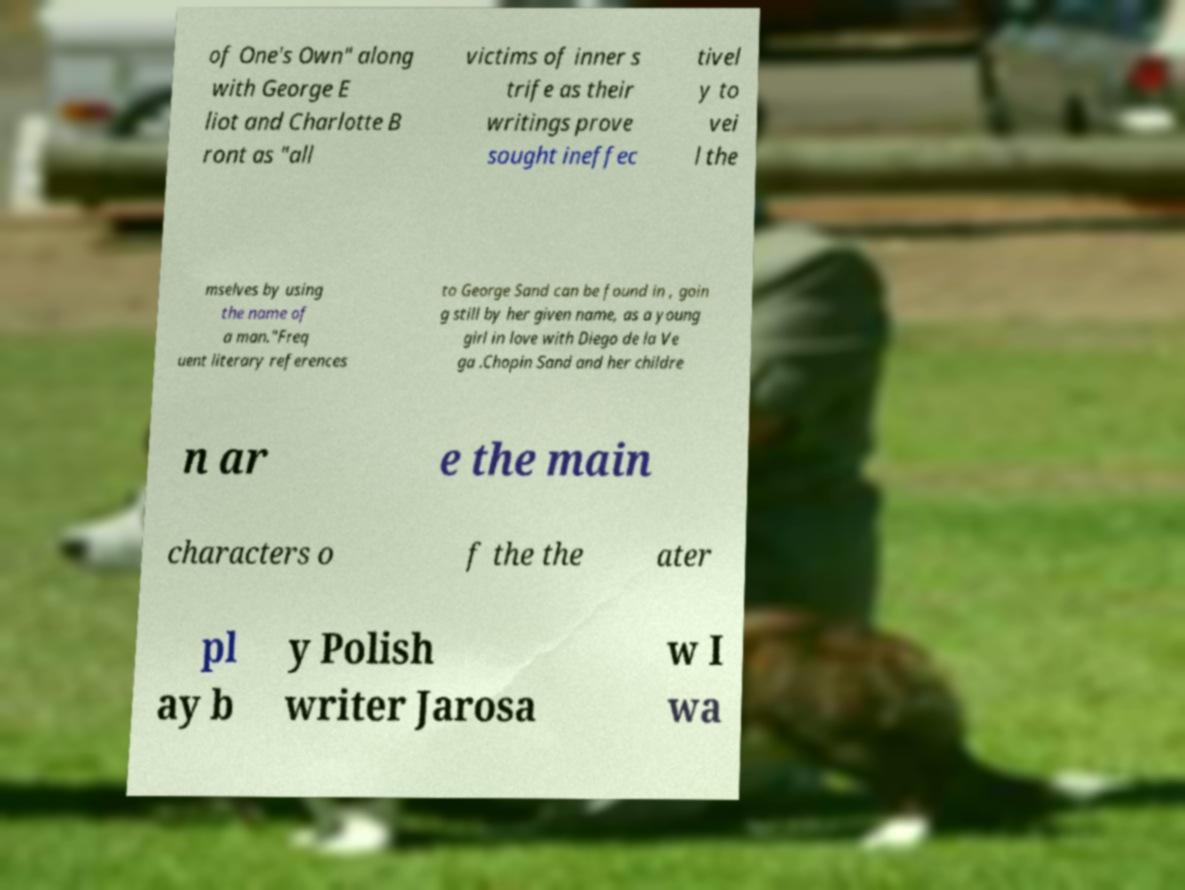Could you assist in decoding the text presented in this image and type it out clearly? of One's Own" along with George E liot and Charlotte B ront as "all victims of inner s trife as their writings prove sought ineffec tivel y to vei l the mselves by using the name of a man."Freq uent literary references to George Sand can be found in , goin g still by her given name, as a young girl in love with Diego de la Ve ga .Chopin Sand and her childre n ar e the main characters o f the the ater pl ay b y Polish writer Jarosa w I wa 